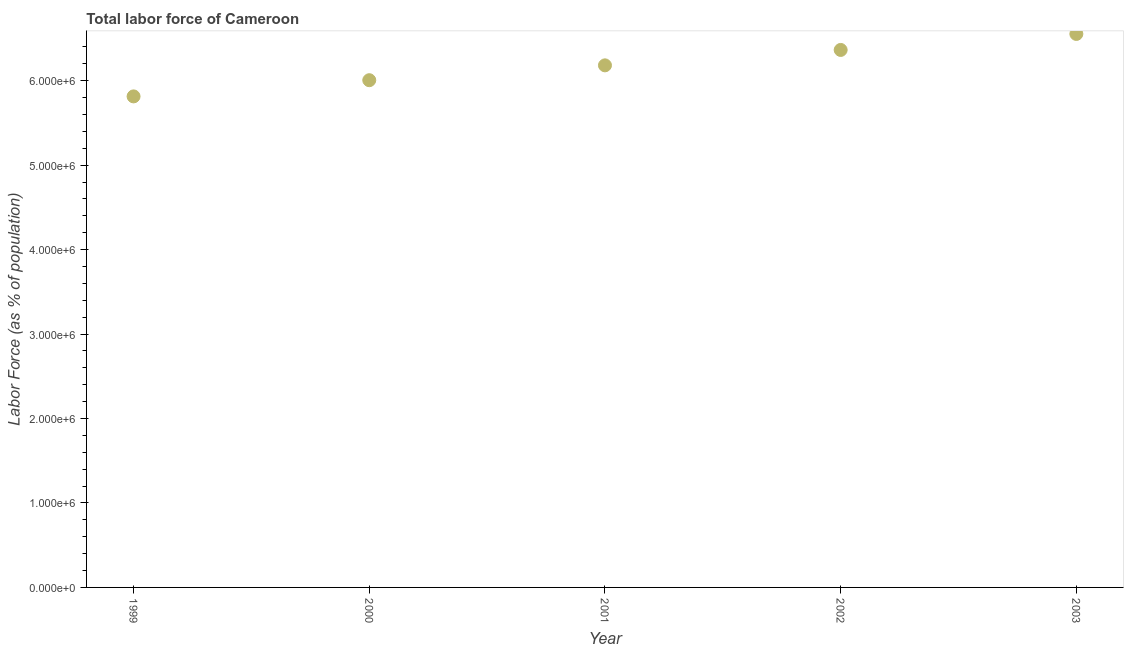What is the total labor force in 2001?
Your answer should be very brief. 6.18e+06. Across all years, what is the maximum total labor force?
Offer a terse response. 6.55e+06. Across all years, what is the minimum total labor force?
Provide a succinct answer. 5.81e+06. In which year was the total labor force maximum?
Offer a very short reply. 2003. What is the sum of the total labor force?
Ensure brevity in your answer.  3.09e+07. What is the difference between the total labor force in 2000 and 2002?
Make the answer very short. -3.58e+05. What is the average total labor force per year?
Keep it short and to the point. 6.18e+06. What is the median total labor force?
Provide a succinct answer. 6.18e+06. Do a majority of the years between 2000 and 2003 (inclusive) have total labor force greater than 4800000 %?
Your answer should be compact. Yes. What is the ratio of the total labor force in 2000 to that in 2003?
Provide a succinct answer. 0.92. What is the difference between the highest and the second highest total labor force?
Keep it short and to the point. 1.89e+05. What is the difference between the highest and the lowest total labor force?
Make the answer very short. 7.39e+05. Does the total labor force monotonically increase over the years?
Offer a very short reply. Yes. How many years are there in the graph?
Your response must be concise. 5. What is the difference between two consecutive major ticks on the Y-axis?
Keep it short and to the point. 1.00e+06. Are the values on the major ticks of Y-axis written in scientific E-notation?
Your answer should be compact. Yes. What is the title of the graph?
Keep it short and to the point. Total labor force of Cameroon. What is the label or title of the Y-axis?
Your response must be concise. Labor Force (as % of population). What is the Labor Force (as % of population) in 1999?
Keep it short and to the point. 5.81e+06. What is the Labor Force (as % of population) in 2000?
Your answer should be very brief. 6.01e+06. What is the Labor Force (as % of population) in 2001?
Offer a very short reply. 6.18e+06. What is the Labor Force (as % of population) in 2002?
Give a very brief answer. 6.36e+06. What is the Labor Force (as % of population) in 2003?
Offer a very short reply. 6.55e+06. What is the difference between the Labor Force (as % of population) in 1999 and 2000?
Provide a succinct answer. -1.92e+05. What is the difference between the Labor Force (as % of population) in 1999 and 2001?
Provide a succinct answer. -3.68e+05. What is the difference between the Labor Force (as % of population) in 1999 and 2002?
Your answer should be very brief. -5.50e+05. What is the difference between the Labor Force (as % of population) in 1999 and 2003?
Make the answer very short. -7.39e+05. What is the difference between the Labor Force (as % of population) in 2000 and 2001?
Keep it short and to the point. -1.76e+05. What is the difference between the Labor Force (as % of population) in 2000 and 2002?
Offer a terse response. -3.58e+05. What is the difference between the Labor Force (as % of population) in 2000 and 2003?
Keep it short and to the point. -5.48e+05. What is the difference between the Labor Force (as % of population) in 2001 and 2002?
Your response must be concise. -1.82e+05. What is the difference between the Labor Force (as % of population) in 2001 and 2003?
Your response must be concise. -3.72e+05. What is the difference between the Labor Force (as % of population) in 2002 and 2003?
Your response must be concise. -1.89e+05. What is the ratio of the Labor Force (as % of population) in 1999 to that in 2001?
Provide a short and direct response. 0.94. What is the ratio of the Labor Force (as % of population) in 1999 to that in 2002?
Offer a very short reply. 0.91. What is the ratio of the Labor Force (as % of population) in 1999 to that in 2003?
Provide a succinct answer. 0.89. What is the ratio of the Labor Force (as % of population) in 2000 to that in 2001?
Your response must be concise. 0.97. What is the ratio of the Labor Force (as % of population) in 2000 to that in 2002?
Provide a succinct answer. 0.94. What is the ratio of the Labor Force (as % of population) in 2000 to that in 2003?
Your response must be concise. 0.92. What is the ratio of the Labor Force (as % of population) in 2001 to that in 2003?
Your response must be concise. 0.94. What is the ratio of the Labor Force (as % of population) in 2002 to that in 2003?
Ensure brevity in your answer.  0.97. 